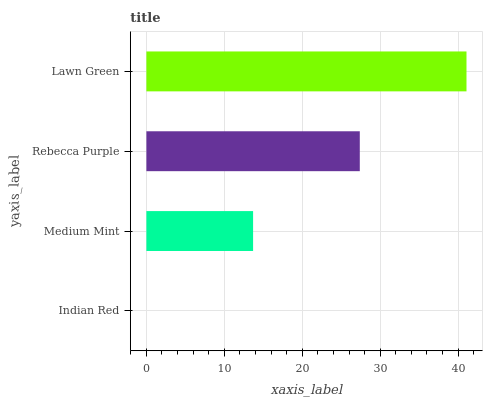Is Indian Red the minimum?
Answer yes or no. Yes. Is Lawn Green the maximum?
Answer yes or no. Yes. Is Medium Mint the minimum?
Answer yes or no. No. Is Medium Mint the maximum?
Answer yes or no. No. Is Medium Mint greater than Indian Red?
Answer yes or no. Yes. Is Indian Red less than Medium Mint?
Answer yes or no. Yes. Is Indian Red greater than Medium Mint?
Answer yes or no. No. Is Medium Mint less than Indian Red?
Answer yes or no. No. Is Rebecca Purple the high median?
Answer yes or no. Yes. Is Medium Mint the low median?
Answer yes or no. Yes. Is Medium Mint the high median?
Answer yes or no. No. Is Indian Red the low median?
Answer yes or no. No. 